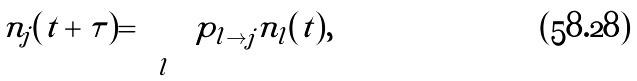<formula> <loc_0><loc_0><loc_500><loc_500>n _ { j } ( t + \tau ) = \sum _ { l } p _ { l \to j } n _ { l } ( t ) ,</formula> 